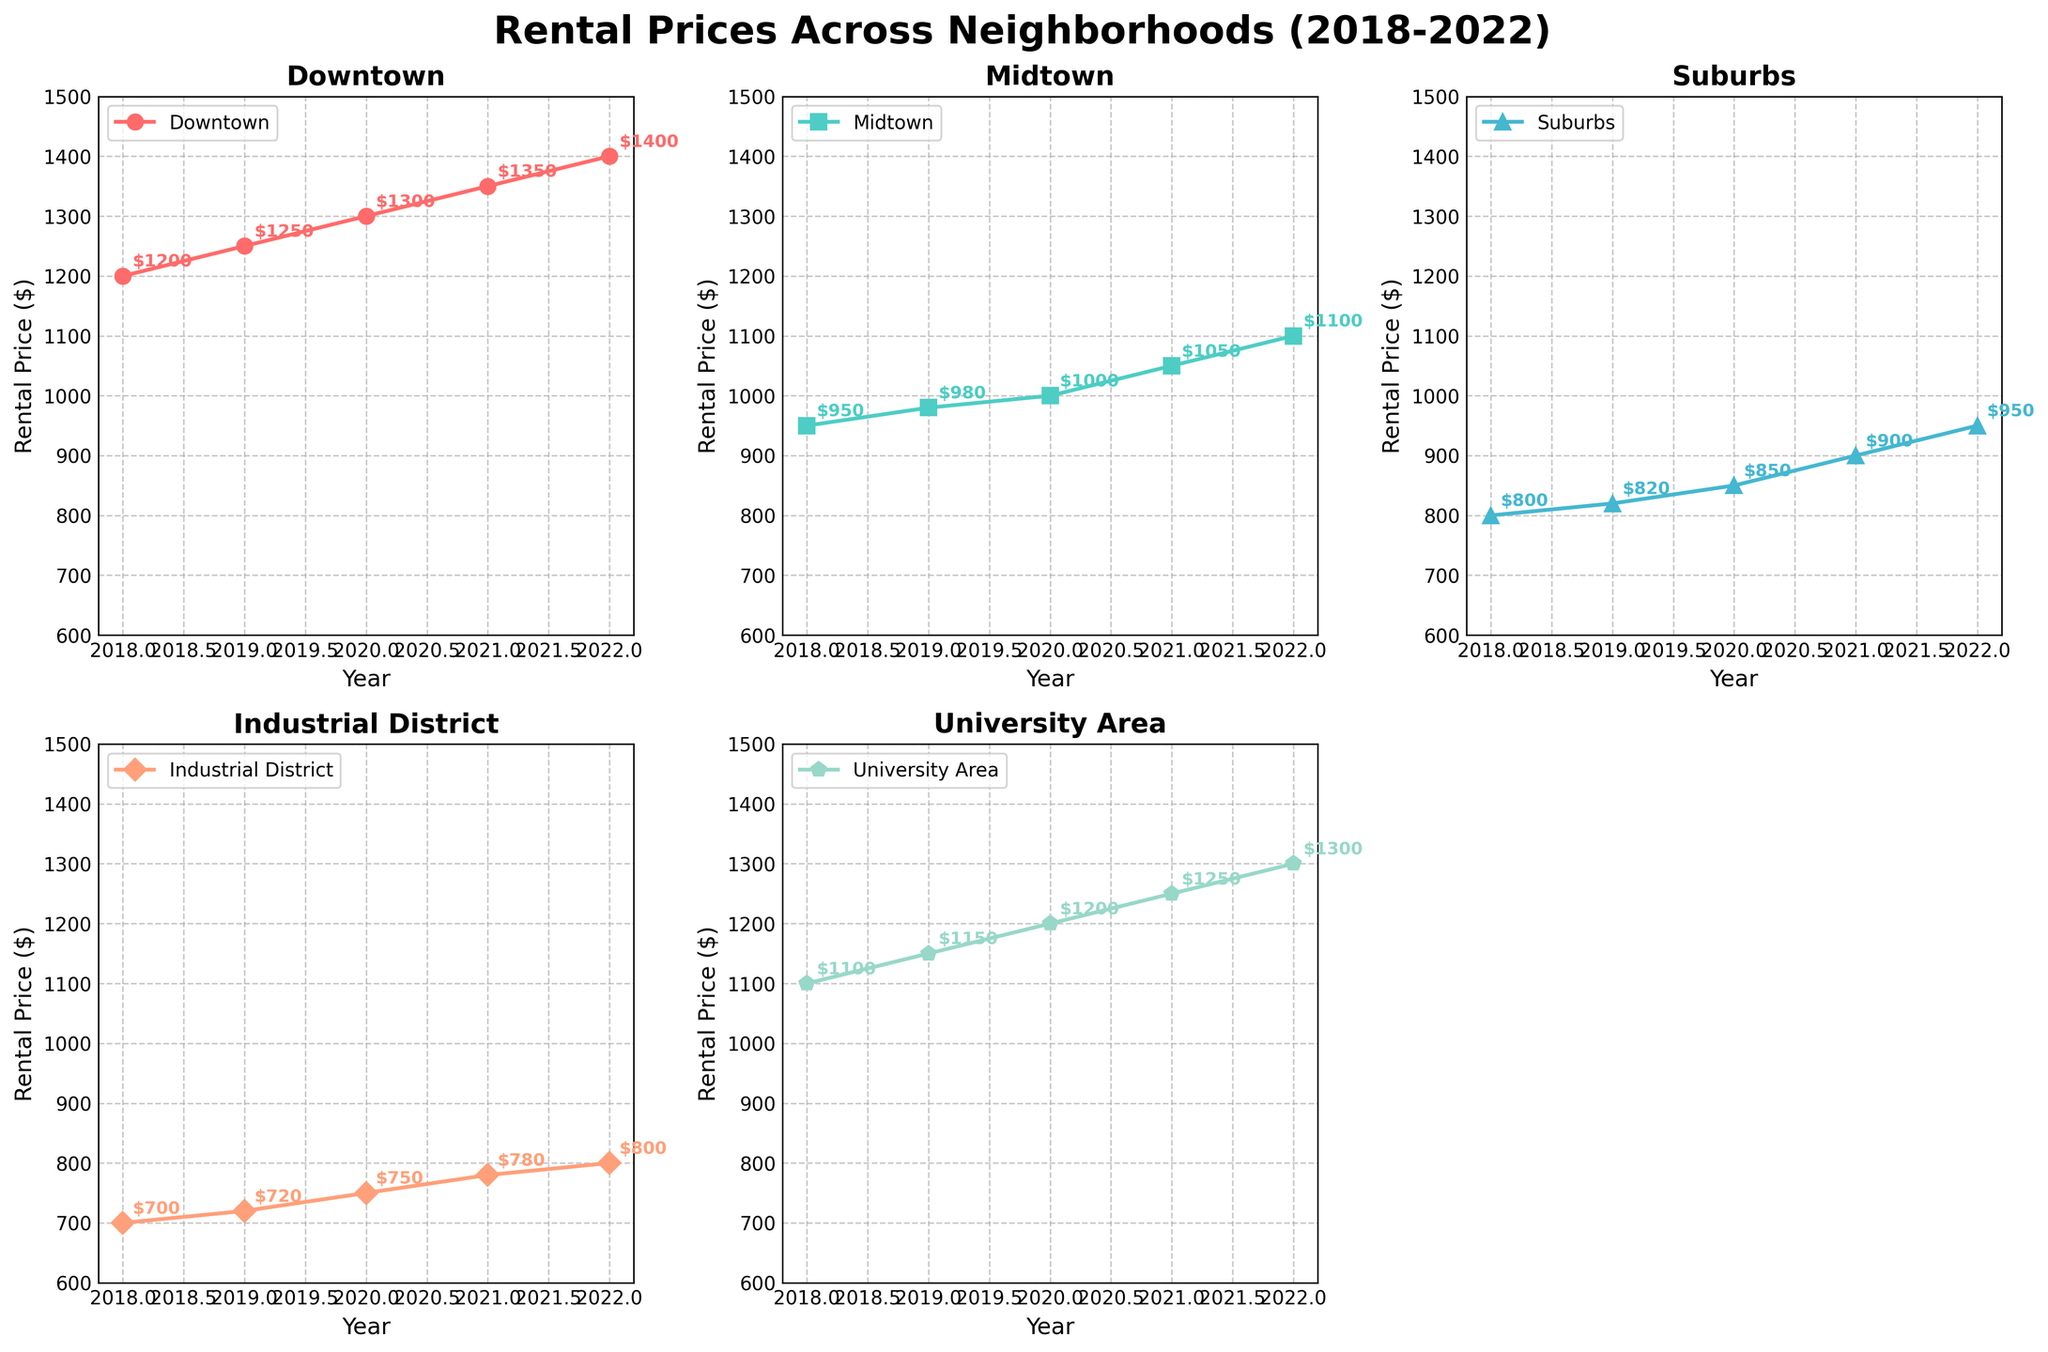What is the rental price in Midtown in 2019? Look at the subplot for Midtown. The data point for the year 2019 has a rental price of $980.
Answer: $980 Which neighborhood had the highest rental price in 2022? Compare the rental prices for all the neighborhoods in the year 2022. Downtown has the highest rental price of $1400.
Answer: Downtown How much did the rental price in the Industrial District increase from 2018 to 2022? Find the rental prices for the Industrial District in 2018 and 2022. Calculate the difference: $800 (2022) - $700 (2018) = $100.
Answer: $100 What is the average rental price in the University Area over the 5 years? Sum the yearly rental prices for the University Area from 2018 to 2022 ($1100 + $1150 + $1200 + $1250 + $1300), which is $6000, and divide by 5 years: $6000/5 = $1200.
Answer: $1200 Between which years did Midtown see the largest increase in rental prices? Calculate the yearly increase for Midtown: 2019-2018 ($980 - $950 = $30), 2020-2019 ($1000 - $980 = $20), 2021-2020 ($1050 - $1000 = $50), 2022-2021 ($1100 - $1050 = $50). The largest increase happened between 2020 and 2021 (or 2021 and 2022).
Answer: 2020 and 2021 Which neighborhood had the least increase in rental prices from 2018 to 2022? Compare the increase in rental prices for all neighborhoods from 2018 to 2022. Calculate the difference for each: Downtown ($1400 - $1200 = $200), Midtown ($1100 - $950 = $150), Suburbs ($950 - $800 = $150), Industrial District ($800 - $700 = $100), University Area ($1300 - $1100 = $200). The Industrial District had the least increase of $100.
Answer: Industrial District 